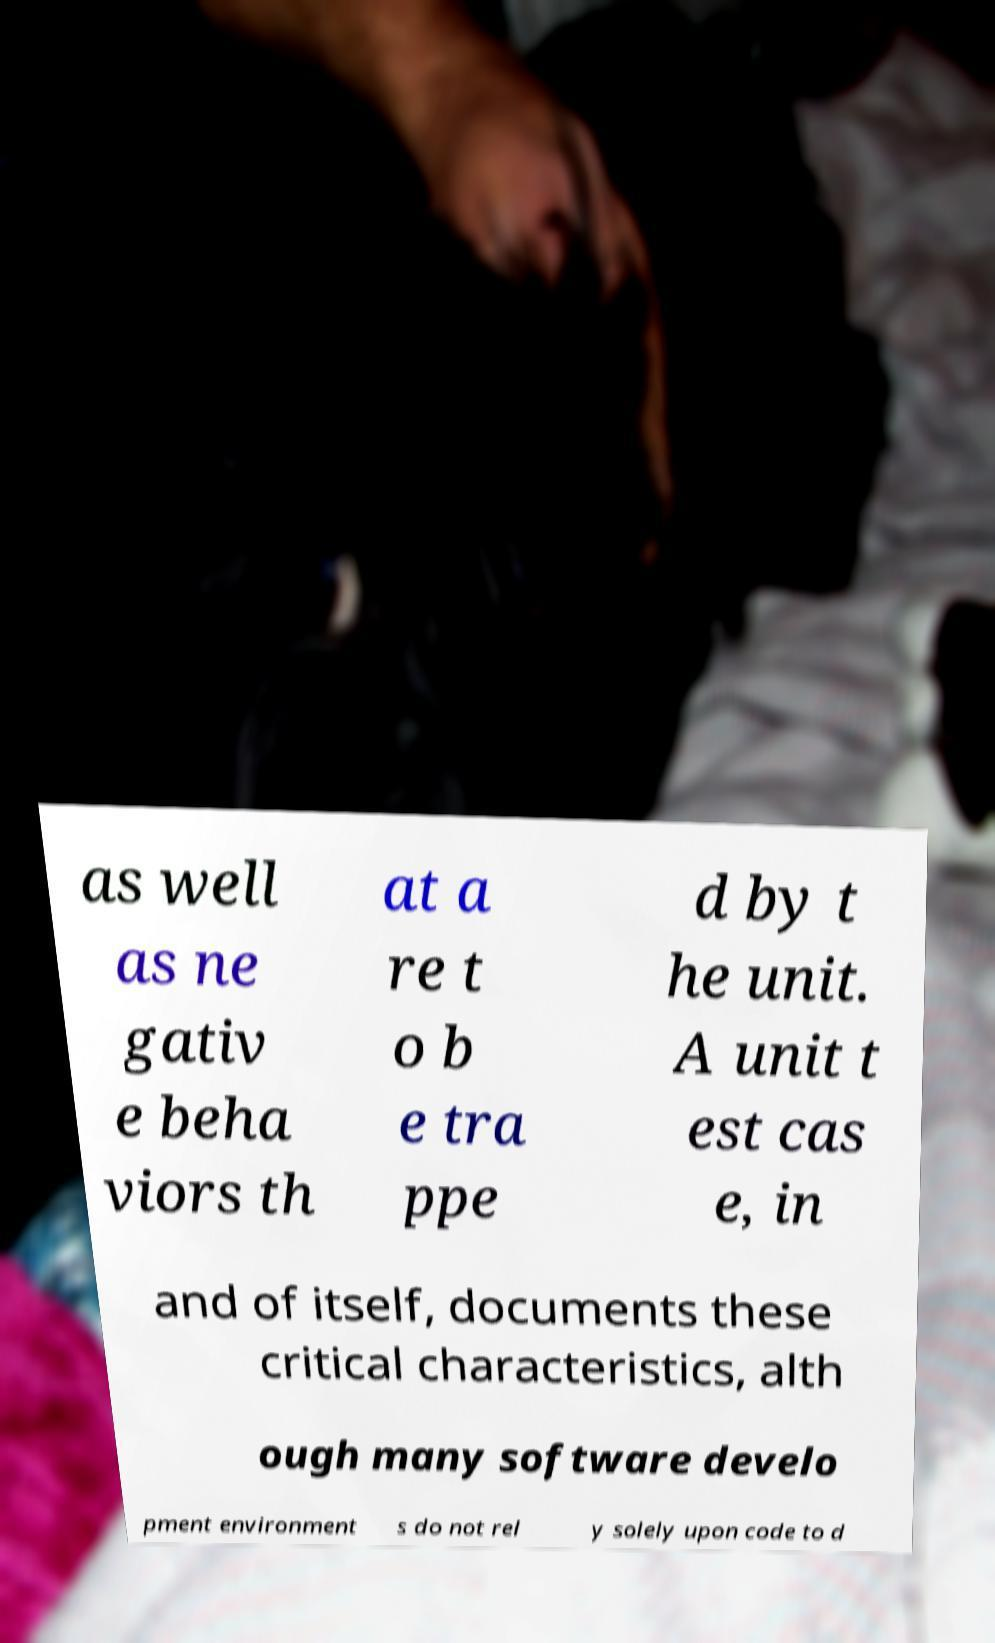Could you assist in decoding the text presented in this image and type it out clearly? as well as ne gativ e beha viors th at a re t o b e tra ppe d by t he unit. A unit t est cas e, in and of itself, documents these critical characteristics, alth ough many software develo pment environment s do not rel y solely upon code to d 